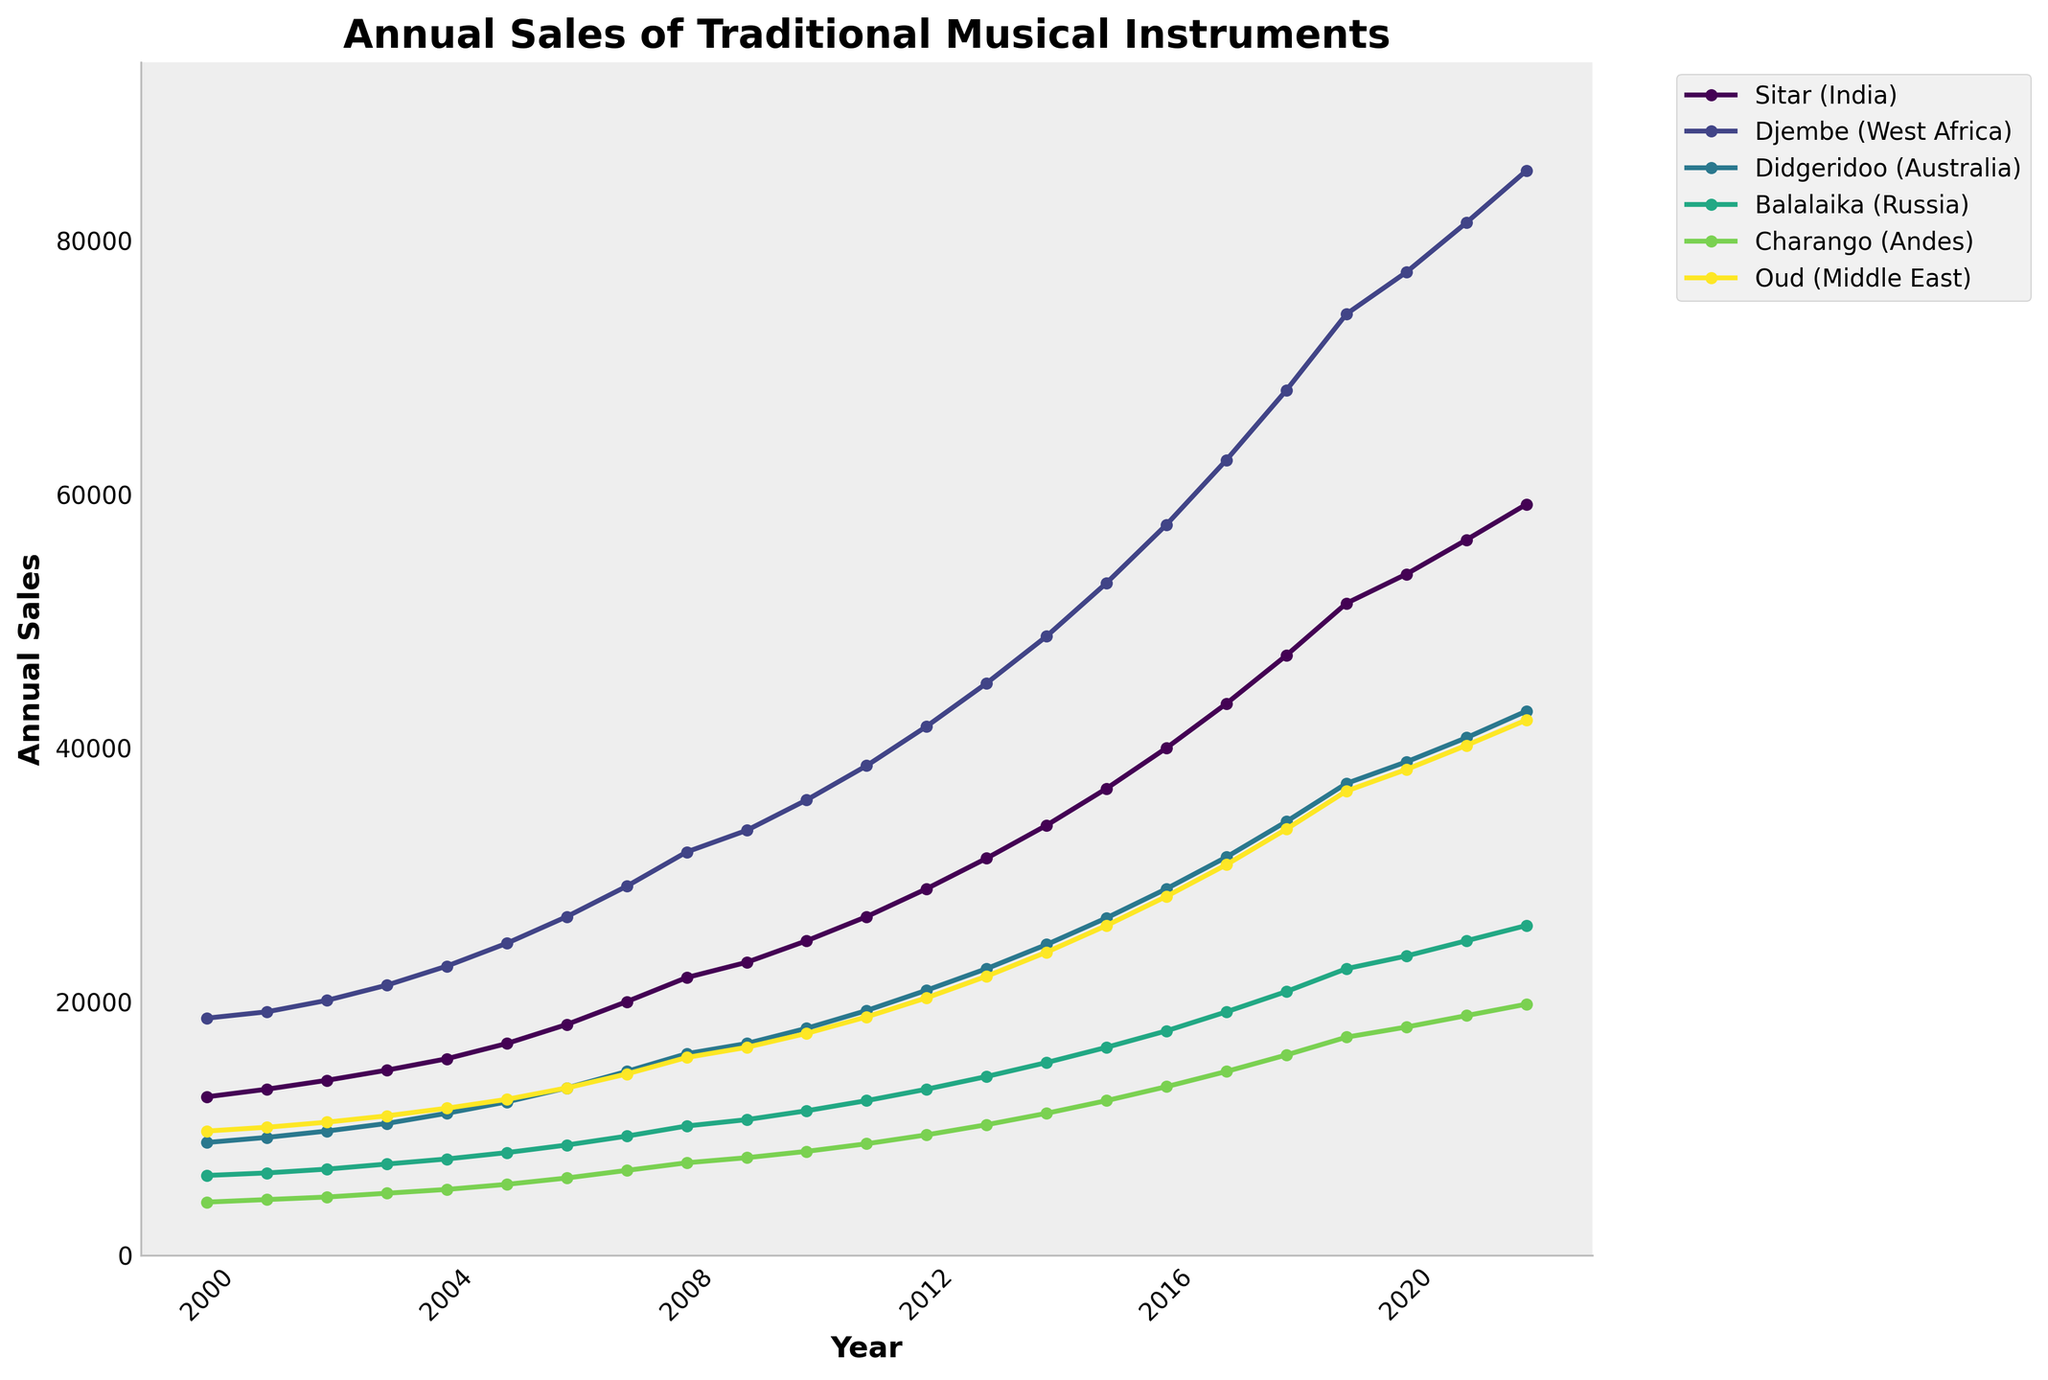Which instrument has the highest annual sales growth from 2000 to 2022? Compare the change in sales from 2000 to 2022 for each instrument. The Sitar starts at 12,500 and increases to 59,200, a growth of 46,700. The Djembe starts at 18,700 and increases to 85,500, a growth of 66,800. The Didgeridoo starts at 8,900 and increases to 42,900, a growth of 34,000. The Balalaika starts at 6,300 and increases to 26,000, a growth of 19,700. The Charango starts at 4,200 and increases to 19,800, a growth of 15,600. The Oud starts at 9,800 and increases to 42,200, a growth of 32,400. Therefore, the Djembe has the highest growth.
Answer: Djembe Which instruments have sales exceeding 30,000 units in 2022? Check the sales values for each instrument in 2022. The Sitar has 59,200, the Djembe has 85,500, the Didgeridoo has 42,900, the Balalaika has 26,000, the Charango has 19,800, and the Oud has 42,200. Instruments with sales exceeding 30,000 are Sitar, Djembe, Didgeridoo, and Oud.
Answer: Sitar, Djembe, Didgeridoo, Oud What is the average annual sales of the Sitar from 2000 to 2022? Sum the annual sales of the Sitar from 2000 to 2022 and divide by the number of years. Sum: 12500 + 13100 + 13800 + 14600 + 15500 + 16700 + 18200 + 20000 + 21900 + 23100 + 24800 + 26700 + 28900 + 31300 + 33900 + 36800 + 40000 + 43500 + 47300 + 51400 + 53700 + 56400 + 59200 = 785300. Average: 785300 / 23 = 34,147.83
Answer: 34,147.83 In which year did the Charango's annual sales first exceed 10,000 units? Check the yearly sales of the Charango. Sales first exceed 10,000 units in 2013 with 10,300 units.
Answer: 2013 Between 2010 and 2020, how many instruments saw their sales more than double? Check sales in 2010 and 2020 for each instrument. For the Sitar, 24,800 to 53,700 (more than double). For the Djembe, 35,900 to 77,500 (more than double). For the Didgeridoo, 17,900 to 38,900 (more than double). The Balalaika, 11,400 to 23,600 (more than double). The Charango, 8,200 to 18,000 (more than double). The Oud, 17,500 to 38,300 (more than double). All instruments saw their sales more than double.
Answer: 6 What is the difference in sales between the Didgeridoo and the Charango in 2022? Subtract the Charango's sales from the Didgeridoo's sales for 2022. 42,900 - 19,800 = 23,100
Answer: 23,100 Which instrument had the smallest increase in sales from 2000 to 2022? Calculate the increase for each instrument from 2000 to 2022 and find the smallest. Sitar: 46,700, Djembe: 66,800, Didgeridoo: 34,000, Balalaika: 19,700, Charango: 15,600, Oud: 32,400. Charango has the smallest increase.
Answer: Charango How much did the sales of the Oud increase between 2015 and 2022? Subtract the Oud sales in 2015 from the sales in 2022. 42,200 - 26,000 = 16,200
Answer: 16,200 In which year did the Djembe sales first surpass 50,000 units? Check the yearly sales of the Djembe. Sales first surpass 50,000 units in 2015 with 53,000 units.
Answer: 2015 What is the combined sales of the Sitar and Djembe in 2022? Add the sales of the Sitar and Djembe in 2022. 59,200 + 85,500 = 144,700
Answer: 144,700 